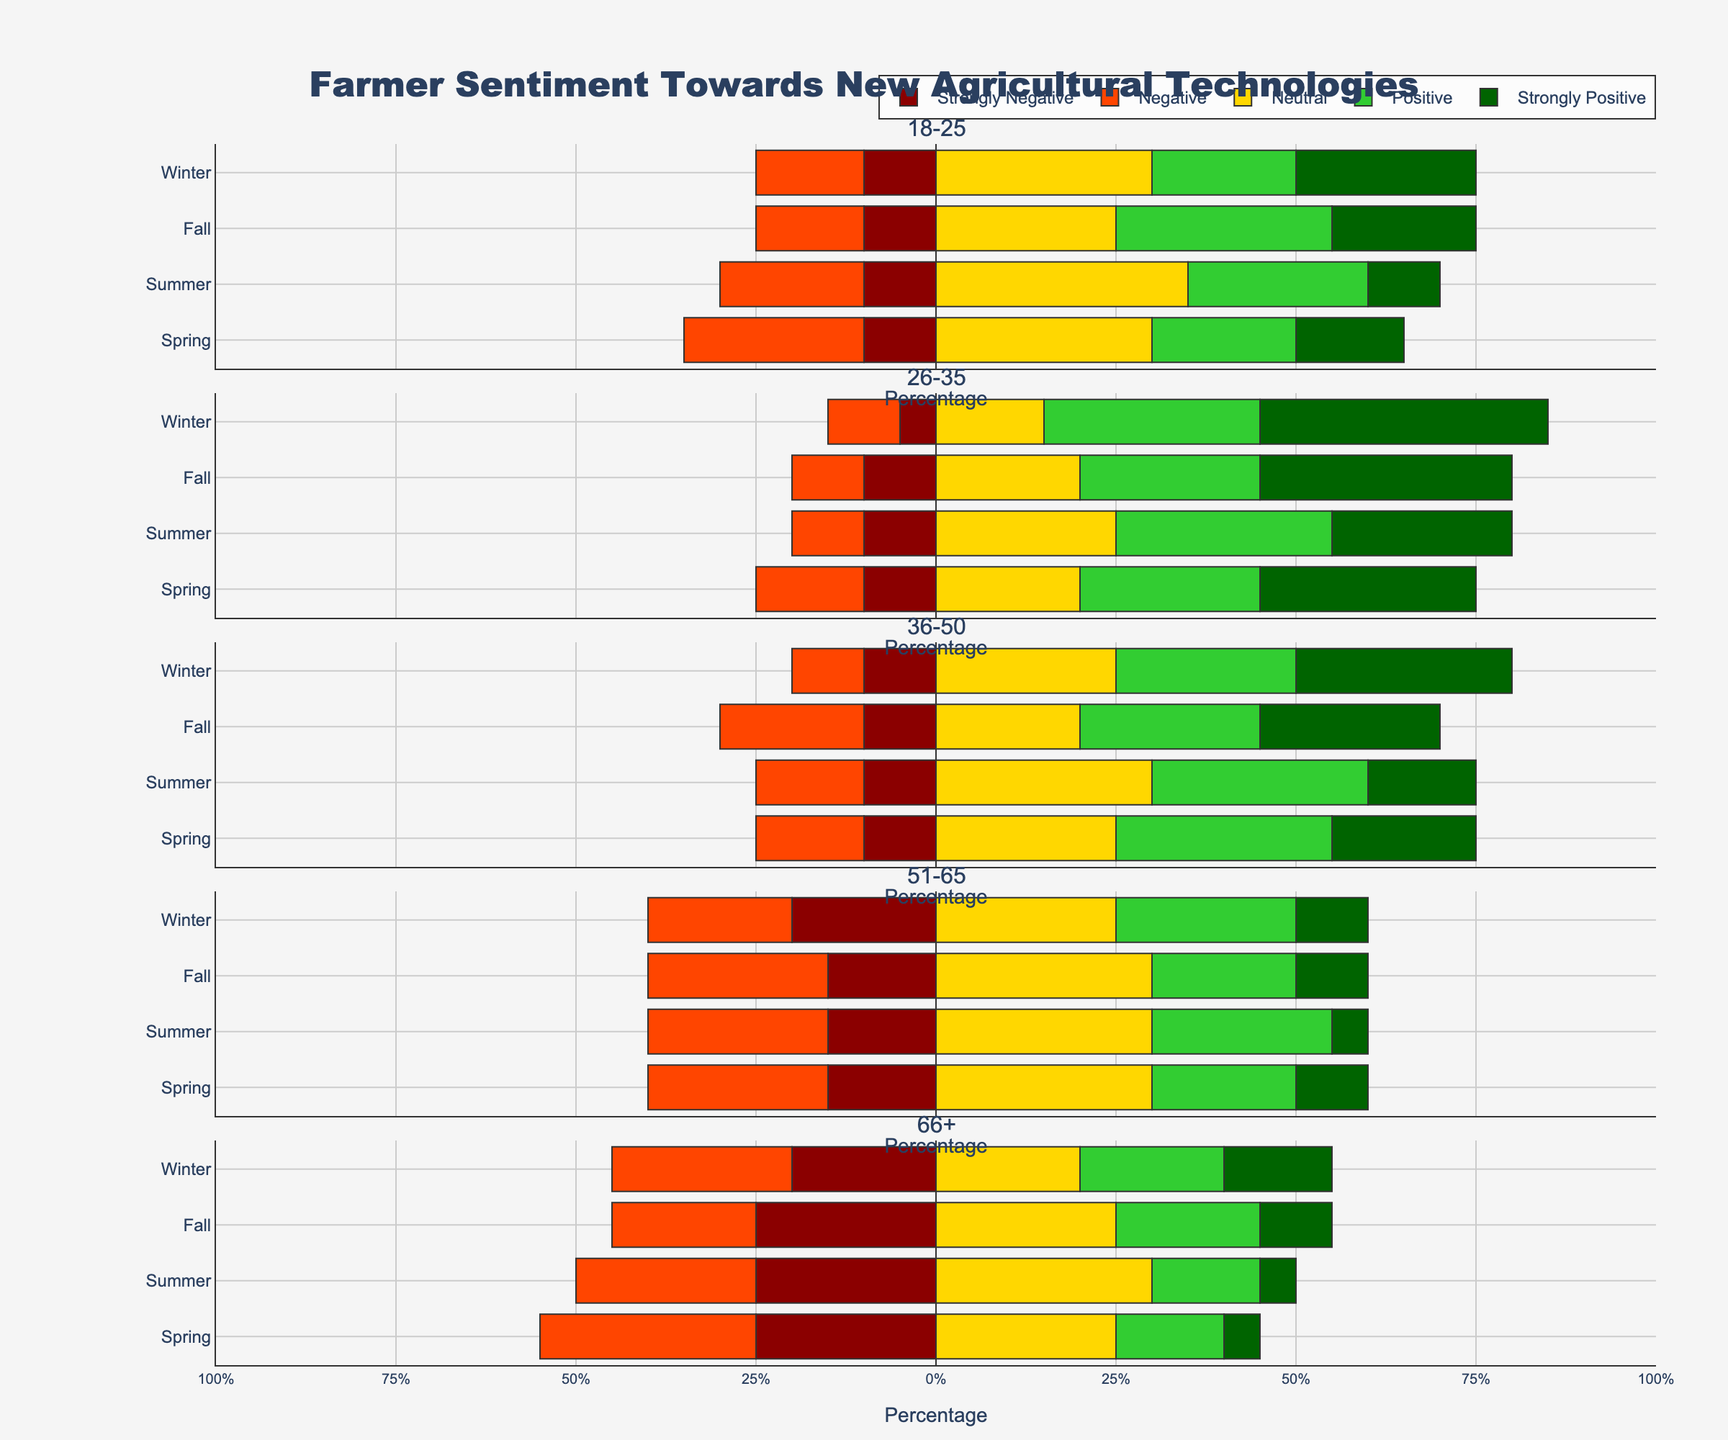What season shows the highest sentiment for the age group 18-25? To find this, look at the bars of age group 18-25 across all seasons and determine where the sum of "Strongly Positive" and "Positive" is the highest. For the age group 18-25, the "Fall" season shows a combined total of 50 (20 Strongly Positive + 30 Positive), which is the highest among them.
Answer: Fall Which age group has the largest proportion of "Strongly Positive" sentiments in Winter? To answer this, compare the "Strongly Positive" bar lengths across different age groups for Winter. Age group 26-35 shows the longest "Strongly Positive" bar at 40 in winter.
Answer: 26-35 Is there any season where the sentiment "Neutral" is higher than any positive sentiments for the age group 36-50? For the age group 36-50, "Neutral" is the longest bar only in "Summer" with 30, which is higher compared to "Positive" and "Strongly Positive" in that season.
Answer: Summer What is the difference between "Neutral" and "Negative" sentiments in Winter for age group 51-65? Look at the "Neutral" (25) and "Negative" (20) sentiments for Winter in the age group 51-65. The difference is 25 - 20 = 5.
Answer: 5 For the age group 66+, which season has the lowest combined "Negative" and "Strongly Negative" sentiments? Examine the "Negative" and "Strongly Negative" bar lengths in all seasons for age group 66+. The combined sentiments for Spring are 30 + 25 = 55, Summer is 25 + 25 = 50, Fall is 20 + 25 = 45, and Winter is 25 + 20 = 45. "Fall" and "Winter" both have the lowest combined values of 45.
Answer: Fall and Winter Which age group shows the highest overall negative sentiment (Negative + Strongly Negative) during Spring? In Spring, sum "Negative" and "Strongly Negative" for each age group: 18-25 (25 + 10 = 35), 26-35 (15 + 10 = 25), 36-50 (15 + 10 = 25), 51-65 (25 + 15 = 40), 66+ (30 + 25 = 55). The age group 66+ has the highest overall negative sentiment at 55.
Answer: 66+ What is the overall sentiment trend for the age group 26-35 across the seasons? For age group 26-35: Spring has highest "Strongly Positive" (30) and "Positive" (25); "Neutral" decreases from Spring to Winter. Fall and Winter have the highest positive sentiments, especially with Winter peaking at 40 "Strongly Positive", showing increasing positive sentiment and decreasing "Negative" and "Strongly Negative" sentiment.
Answer: Increasing positive trend Is there any age group that shows a consistently high or low "Neutral" sentiment across all seasons? Evaluate the "Neutral" sentiment for each age group across all seasons. The age group 51-65 maintains high "Neutral" values (30 in Spring and Fall, 25 in Summer and Winter) consistently across all seasons.
Answer: Age group 51-65 